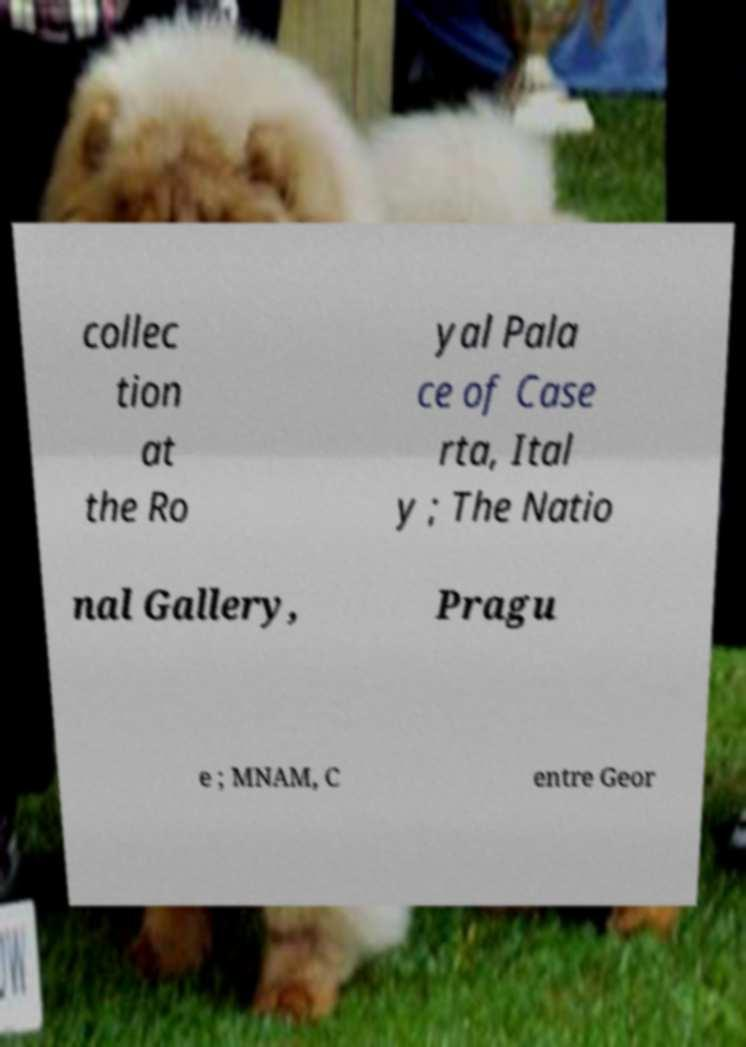Could you extract and type out the text from this image? collec tion at the Ro yal Pala ce of Case rta, Ital y ; The Natio nal Gallery, Pragu e ; MNAM, C entre Geor 